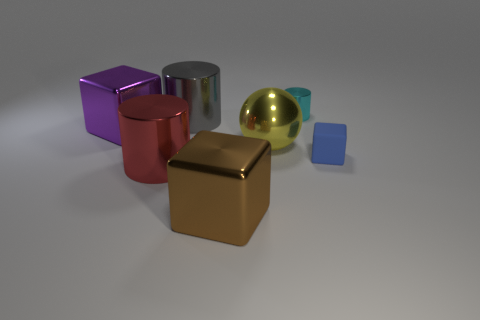Subtract all gray cylinders. How many cylinders are left? 2 Add 1 big brown metal objects. How many objects exist? 8 Subtract all red cylinders. How many cylinders are left? 2 Subtract 1 cylinders. How many cylinders are left? 2 Subtract all large blue metallic things. Subtract all large yellow spheres. How many objects are left? 6 Add 2 purple shiny cubes. How many purple shiny cubes are left? 3 Add 4 cyan cylinders. How many cyan cylinders exist? 5 Subtract 0 gray cubes. How many objects are left? 7 Subtract all blocks. How many objects are left? 4 Subtract all purple cylinders. Subtract all blue balls. How many cylinders are left? 3 